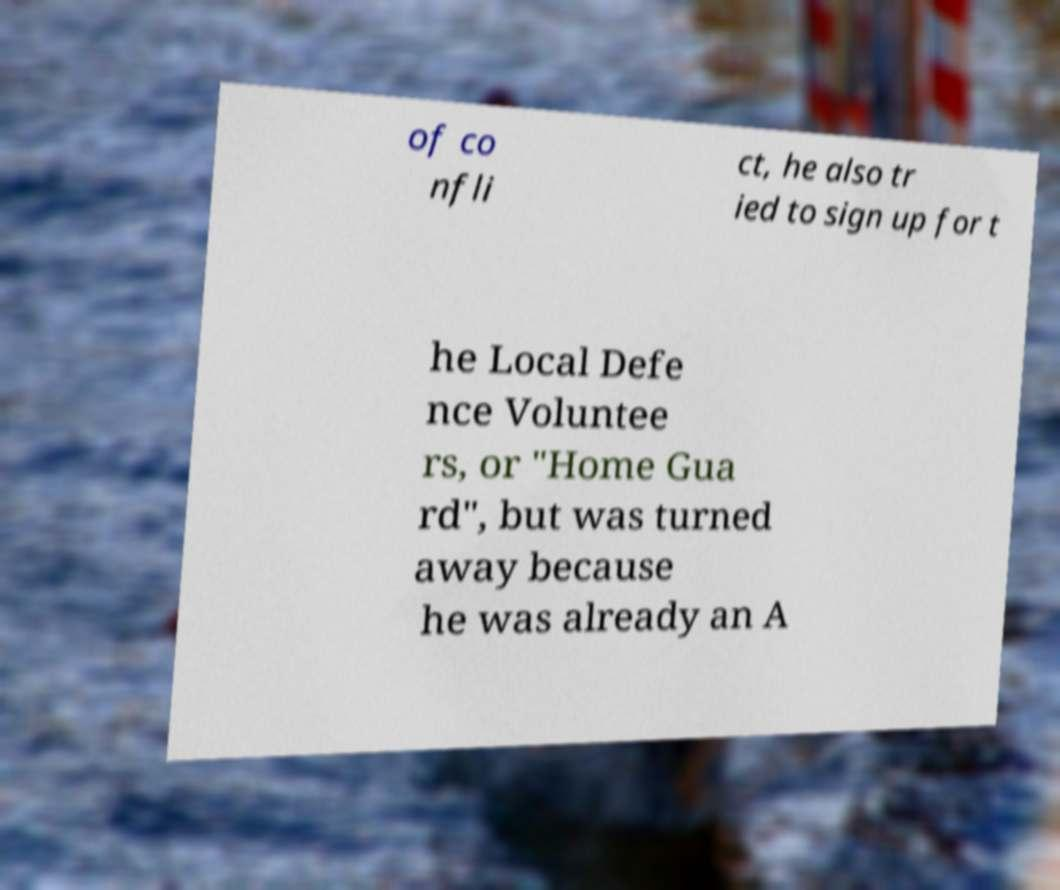Can you accurately transcribe the text from the provided image for me? of co nfli ct, he also tr ied to sign up for t he Local Defe nce Voluntee rs, or "Home Gua rd", but was turned away because he was already an A 